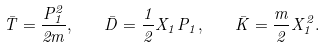Convert formula to latex. <formula><loc_0><loc_0><loc_500><loc_500>\bar { T } = \frac { P _ { 1 } ^ { 2 } } { 2 m } , \quad \bar { D } = \frac { 1 } { 2 } X _ { 1 } P _ { 1 } , \quad \bar { K } = \frac { m } { 2 } X _ { 1 } ^ { 2 } .</formula> 